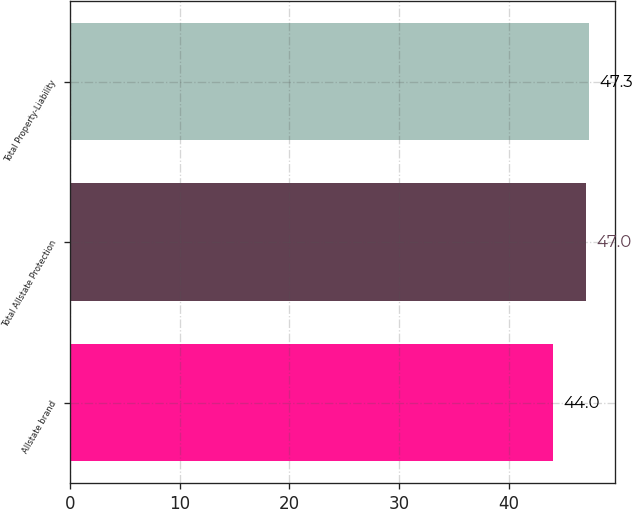Convert chart to OTSL. <chart><loc_0><loc_0><loc_500><loc_500><bar_chart><fcel>Allstate brand<fcel>Total Allstate Protection<fcel>Total Property-Liability<nl><fcel>44<fcel>47<fcel>47.3<nl></chart> 